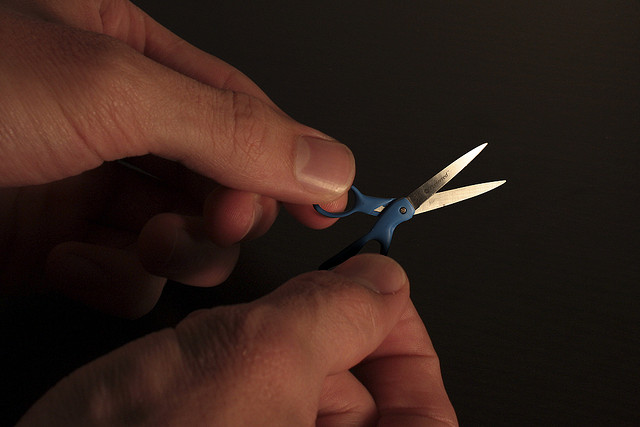<image>How is the picture? I am not sure how is the picture. It can be small scissor, distinct or focused. How is the picture? I don't know how the picture is. It can be small scissors, distinct, focused, normal, or clear. 